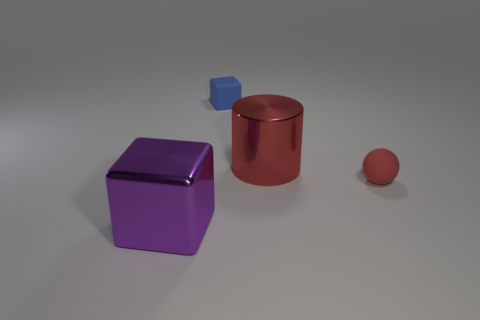Is the rubber cube the same color as the big shiny cube?
Provide a short and direct response. No. What size is the object that is in front of the big cylinder and right of the rubber cube?
Make the answer very short. Small. What is the shape of the small red thing?
Provide a succinct answer. Sphere. How many things are tiny green metallic balls or cubes behind the tiny red rubber object?
Offer a terse response. 1. There is a block behind the large red cylinder; is its color the same as the tiny sphere?
Offer a terse response. No. What is the color of the thing that is on the left side of the big red metallic object and behind the tiny red rubber ball?
Ensure brevity in your answer.  Blue. What is the material of the object to the left of the small blue block?
Make the answer very short. Metal. The purple object has what size?
Ensure brevity in your answer.  Large. What number of purple objects are either large spheres or big blocks?
Ensure brevity in your answer.  1. There is a blue cube behind the red rubber thing that is behind the big metal cube; how big is it?
Offer a very short reply. Small. 